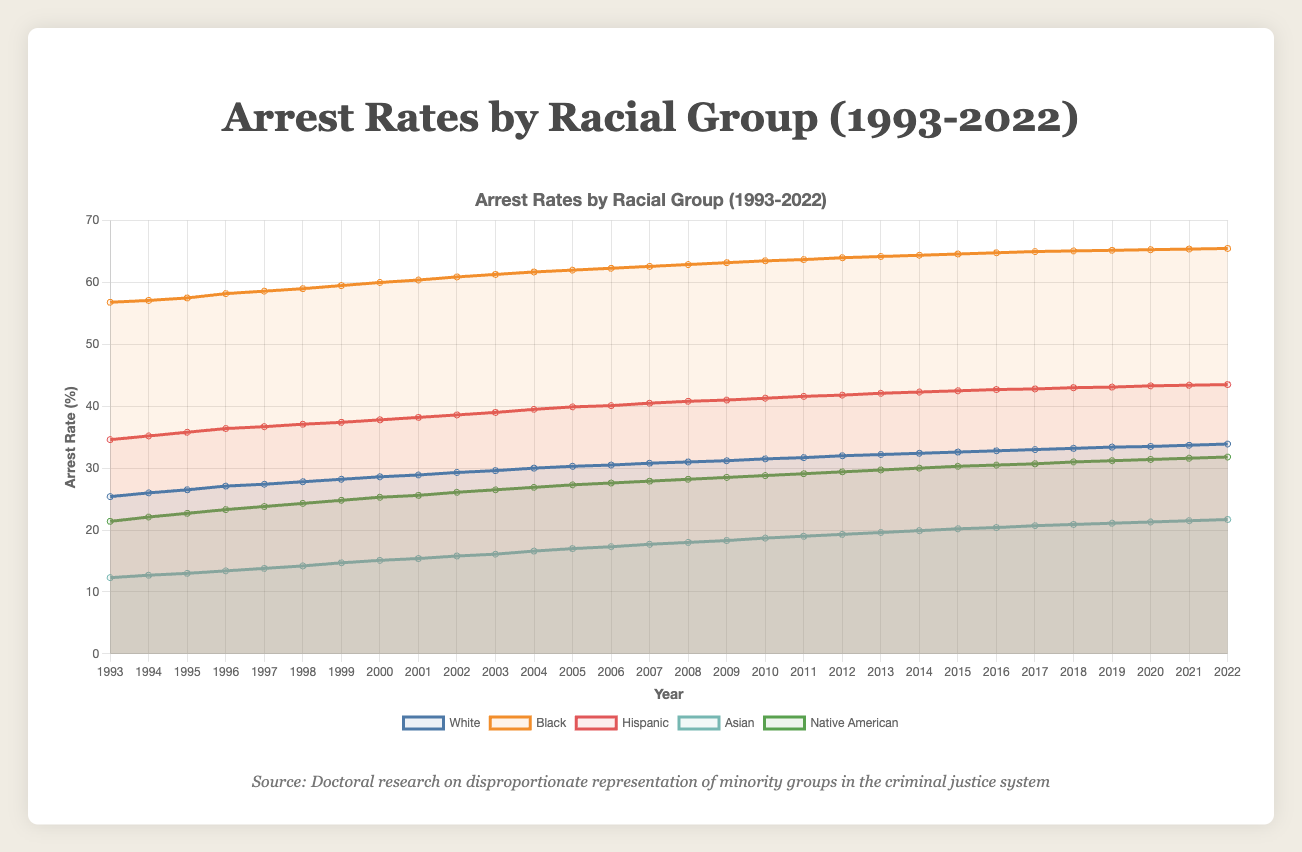What was the arrest rate for the Black group in 2000? By looking at the data for the year 2000 under the "Black" column, the arrest rate can be identified.
Answer: 60.0 Which group had the lowest arrest rate in 1993? By comparing the arrest rates for all groups in 1993, the lowest value corresponds to the Asian group.
Answer: Asian In what year did the Hispanic group's arrest rate surpass 40%? By examining each year's data for the Hispanic group, the arrest rate surpasses 40% in the year 2006.
Answer: 2006 Compare the arrest rates of the White and Native American groups in 2022. By looking at the values for both groups in 2022, the White arrest rate is 33.9 and the Native American arrest rate is 31.8. Therefore, the White arrest rate is higher.
Answer: White What is the average arrest rate of the Hispanic group from 2000 to 2005? Add the arrest rates for the Hispanic group from 2000 to 2005 and divide by the number of years: (37.8 + 38.2 + 38.6 + 39.0 + 39.5 + 39.9)/6. The sum is 233.0, so the average is 233.0/6 = 38.83.
Answer: 38.83 Identify the year when the arrest rate for Asians was equal to 20.7. The Asian arrest rate is 20.7 in the year 2017 as identified in the data.
Answer: 2017 How much did the Native American group's arrest rate increase from 1993 to 2022? Subtract the arrest rate of Native American group in 1993 from that in 2022: 31.8 - 21.4. The increase is 10.4.
Answer: 10.4 During which year did the Black group see the highest arrest rate? By reviewing each year’s data for the Black group, the highest value is 65.5 in the year 2022.
Answer: 2022 What was the combined arrest rate of the Hispanic and White groups in 2010? Add the arrest rates for the Hispanic and White groups in the year 2010: 41.3 + 31.5. The combined rate is 72.8.
Answer: 72.8 Calculate the median arrest rate of the Asian group over the last 10 years (2013-2022). First, list the Asian arrest rates from 2013 to 2022: 19.6, 19.9, 20.2, 20.4, 20.7, 20.9, 21.1, 21.3, 21.5, 21.7. Arrange them: 19.6, 19.9, 20.2, 20.4, 20.7, 20.9, 21.1, 21.3, 21.5, 21.7. The median is the average of the 5th and 6th values (20.7 and 20.9), thus (20.7 + 20.9)/2 = 20.8.
Answer: 20.8 